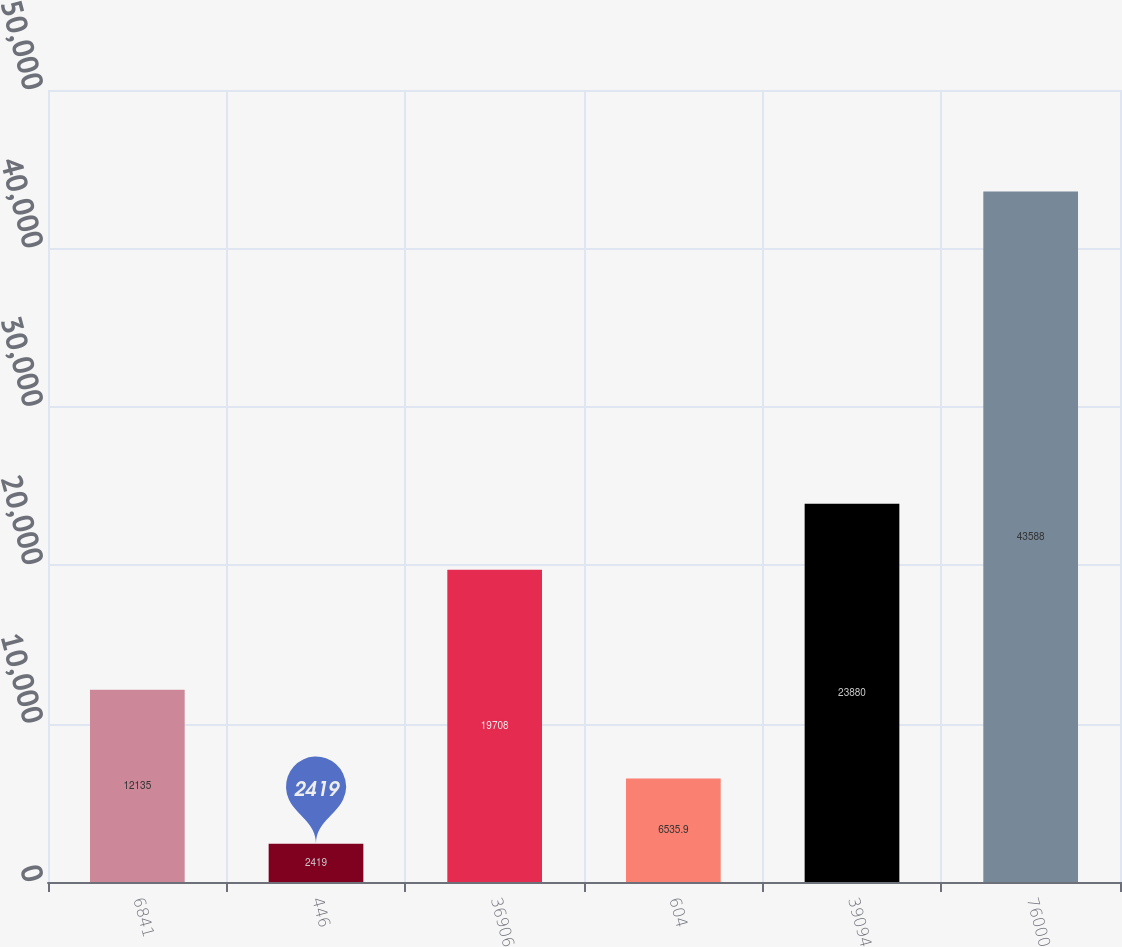<chart> <loc_0><loc_0><loc_500><loc_500><bar_chart><fcel>6841<fcel>446<fcel>36906<fcel>604<fcel>39094<fcel>76000<nl><fcel>12135<fcel>2419<fcel>19708<fcel>6535.9<fcel>23880<fcel>43588<nl></chart> 